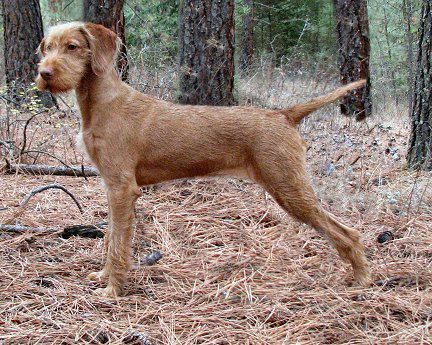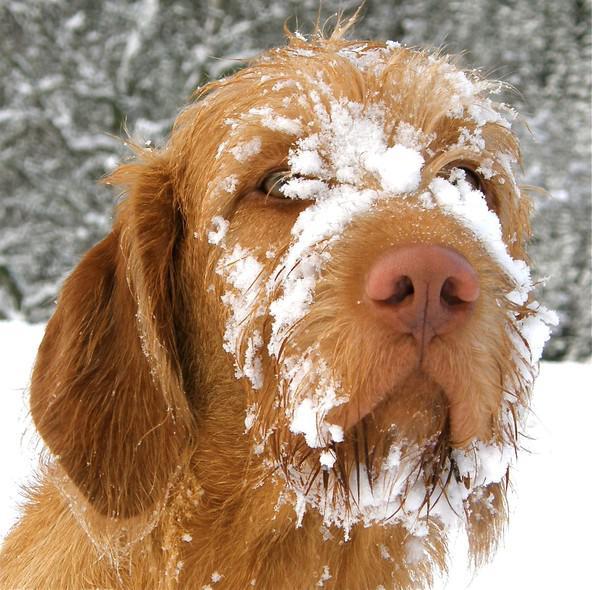The first image is the image on the left, the second image is the image on the right. Analyze the images presented: Is the assertion "The right image features one dog in a sitting pose with body turned left and head turned straight, and the left image features a reclining mother dog with at least four puppies in front of her." valid? Answer yes or no. No. The first image is the image on the left, the second image is the image on the right. Considering the images on both sides, is "At least 4 puppies are laying on the ground next to their mama." valid? Answer yes or no. No. 